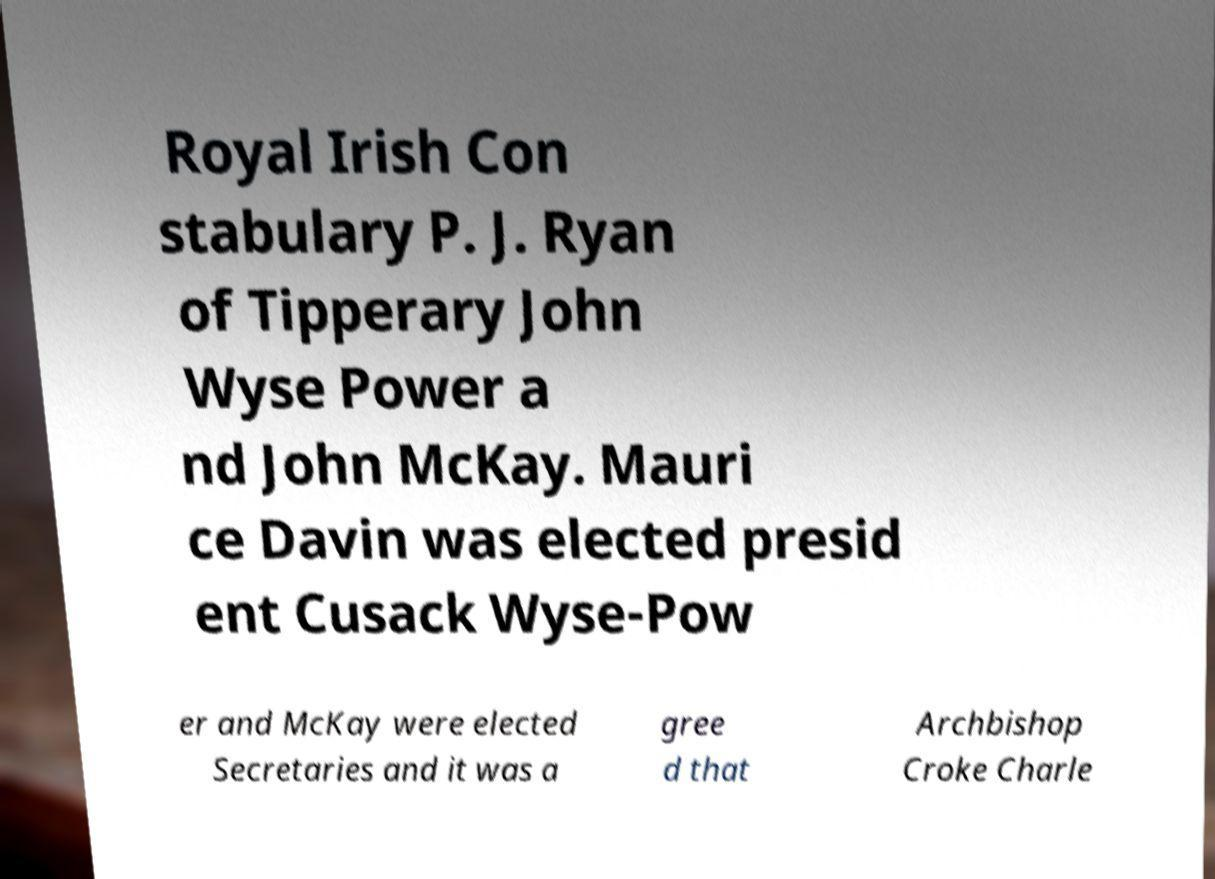For documentation purposes, I need the text within this image transcribed. Could you provide that? Royal Irish Con stabulary P. J. Ryan of Tipperary John Wyse Power a nd John McKay. Mauri ce Davin was elected presid ent Cusack Wyse-Pow er and McKay were elected Secretaries and it was a gree d that Archbishop Croke Charle 